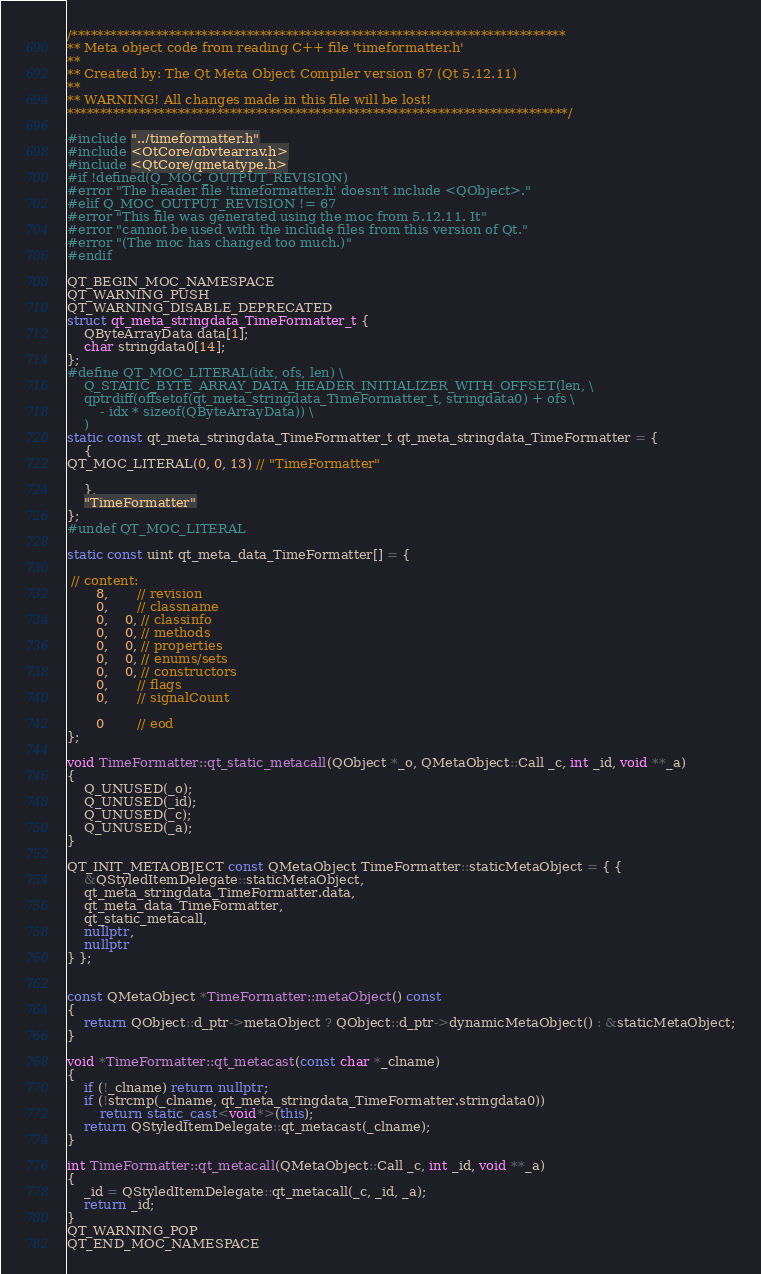Convert code to text. <code><loc_0><loc_0><loc_500><loc_500><_C++_>/****************************************************************************
** Meta object code from reading C++ file 'timeformatter.h'
**
** Created by: The Qt Meta Object Compiler version 67 (Qt 5.12.11)
**
** WARNING! All changes made in this file will be lost!
*****************************************************************************/

#include "../timeformatter.h"
#include <QtCore/qbytearray.h>
#include <QtCore/qmetatype.h>
#if !defined(Q_MOC_OUTPUT_REVISION)
#error "The header file 'timeformatter.h' doesn't include <QObject>."
#elif Q_MOC_OUTPUT_REVISION != 67
#error "This file was generated using the moc from 5.12.11. It"
#error "cannot be used with the include files from this version of Qt."
#error "(The moc has changed too much.)"
#endif

QT_BEGIN_MOC_NAMESPACE
QT_WARNING_PUSH
QT_WARNING_DISABLE_DEPRECATED
struct qt_meta_stringdata_TimeFormatter_t {
    QByteArrayData data[1];
    char stringdata0[14];
};
#define QT_MOC_LITERAL(idx, ofs, len) \
    Q_STATIC_BYTE_ARRAY_DATA_HEADER_INITIALIZER_WITH_OFFSET(len, \
    qptrdiff(offsetof(qt_meta_stringdata_TimeFormatter_t, stringdata0) + ofs \
        - idx * sizeof(QByteArrayData)) \
    )
static const qt_meta_stringdata_TimeFormatter_t qt_meta_stringdata_TimeFormatter = {
    {
QT_MOC_LITERAL(0, 0, 13) // "TimeFormatter"

    },
    "TimeFormatter"
};
#undef QT_MOC_LITERAL

static const uint qt_meta_data_TimeFormatter[] = {

 // content:
       8,       // revision
       0,       // classname
       0,    0, // classinfo
       0,    0, // methods
       0,    0, // properties
       0,    0, // enums/sets
       0,    0, // constructors
       0,       // flags
       0,       // signalCount

       0        // eod
};

void TimeFormatter::qt_static_metacall(QObject *_o, QMetaObject::Call _c, int _id, void **_a)
{
    Q_UNUSED(_o);
    Q_UNUSED(_id);
    Q_UNUSED(_c);
    Q_UNUSED(_a);
}

QT_INIT_METAOBJECT const QMetaObject TimeFormatter::staticMetaObject = { {
    &QStyledItemDelegate::staticMetaObject,
    qt_meta_stringdata_TimeFormatter.data,
    qt_meta_data_TimeFormatter,
    qt_static_metacall,
    nullptr,
    nullptr
} };


const QMetaObject *TimeFormatter::metaObject() const
{
    return QObject::d_ptr->metaObject ? QObject::d_ptr->dynamicMetaObject() : &staticMetaObject;
}

void *TimeFormatter::qt_metacast(const char *_clname)
{
    if (!_clname) return nullptr;
    if (!strcmp(_clname, qt_meta_stringdata_TimeFormatter.stringdata0))
        return static_cast<void*>(this);
    return QStyledItemDelegate::qt_metacast(_clname);
}

int TimeFormatter::qt_metacall(QMetaObject::Call _c, int _id, void **_a)
{
    _id = QStyledItemDelegate::qt_metacall(_c, _id, _a);
    return _id;
}
QT_WARNING_POP
QT_END_MOC_NAMESPACE
</code> 